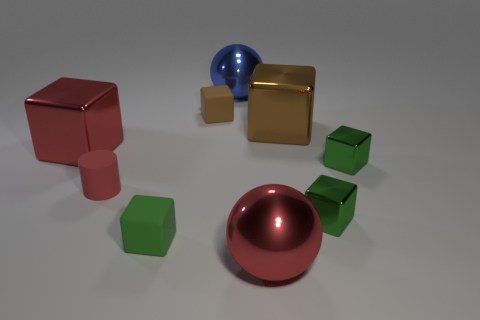How many things are either big metallic balls that are in front of the small brown rubber block or tiny green things that are behind the tiny matte cylinder?
Keep it short and to the point. 2. There is a brown thing that is the same size as the red metal cube; what is its material?
Provide a succinct answer. Metal. What color is the small cylinder?
Your answer should be very brief. Red. What material is the red thing that is both in front of the big red cube and behind the big red sphere?
Your answer should be compact. Rubber. Are there any large red metal cubes that are on the left side of the brown block to the right of the big sphere that is in front of the matte cylinder?
Keep it short and to the point. Yes. Are there any red spheres behind the red metallic ball?
Provide a short and direct response. No. How many other things are there of the same shape as the brown matte thing?
Keep it short and to the point. 5. There is a metallic sphere that is the same size as the blue object; what color is it?
Offer a very short reply. Red. Is the number of large metal blocks that are left of the small brown matte thing less than the number of tiny blocks in front of the brown shiny thing?
Ensure brevity in your answer.  Yes. There is a tiny green rubber block on the left side of the big red object to the right of the red metallic block; what number of tiny green objects are behind it?
Your answer should be compact. 2. 